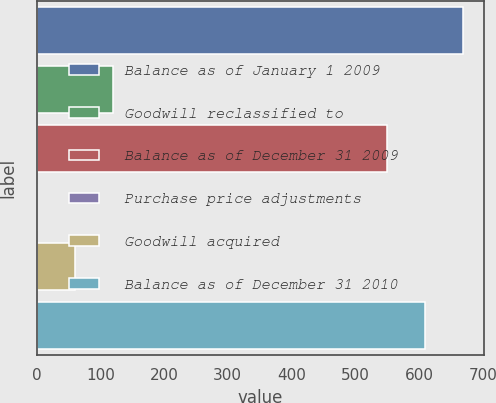Convert chart. <chart><loc_0><loc_0><loc_500><loc_500><bar_chart><fcel>Balance as of January 1 2009<fcel>Goodwill reclassified to<fcel>Balance as of December 31 2009<fcel>Purchase price adjustments<fcel>Goodwill acquired<fcel>Balance as of December 31 2010<nl><fcel>668.2<fcel>120.2<fcel>549<fcel>1<fcel>60.6<fcel>608.6<nl></chart> 